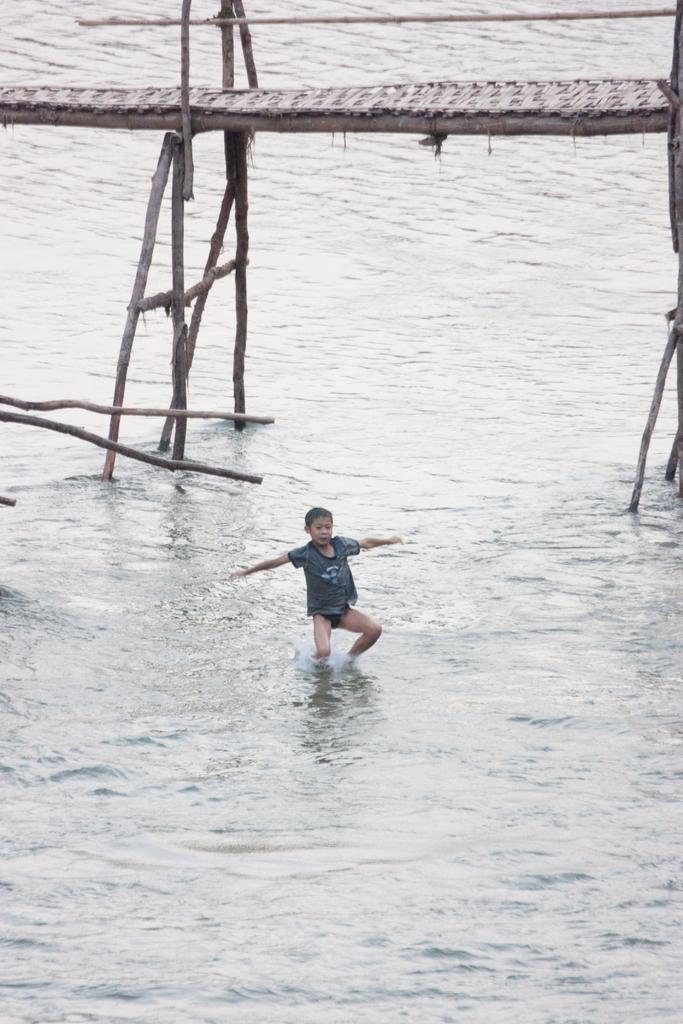What is the main subject of the image? There is a person in the image. What can be seen in the background of the image? There is water and a bridge in the image. What type of hat is the person wearing in the image? There is no hat visible in the image. Can you hear a bell ringing in the image? There is no bell present in the image, so it cannot be heard. 